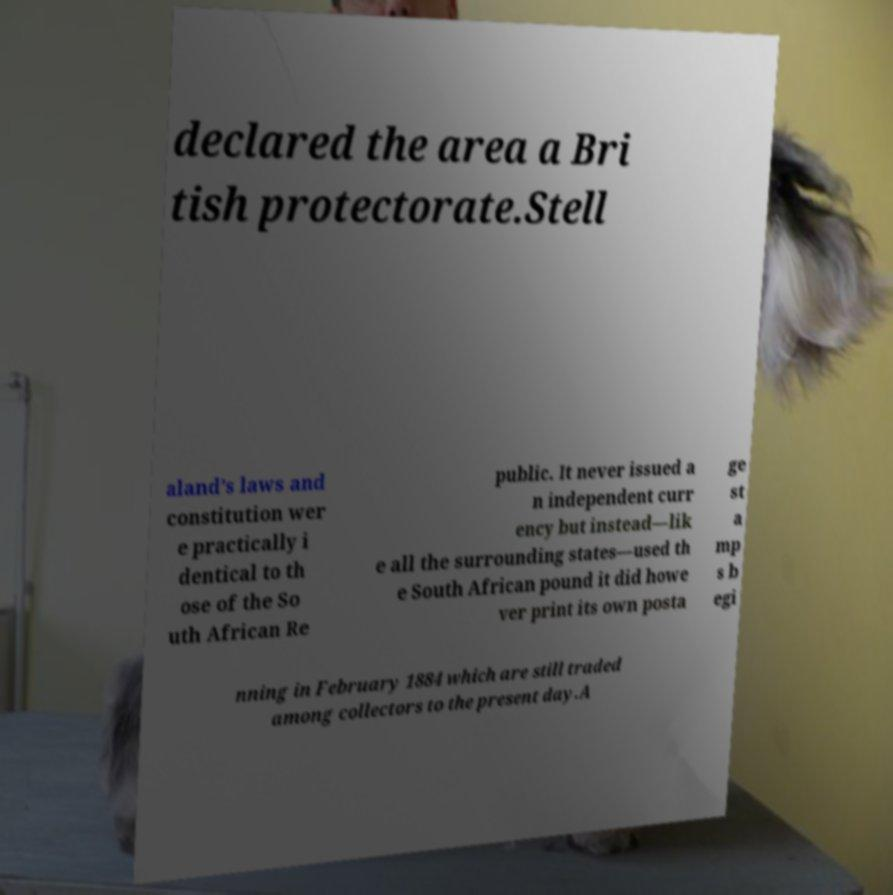I need the written content from this picture converted into text. Can you do that? declared the area a Bri tish protectorate.Stell aland’s laws and constitution wer e practically i dentical to th ose of the So uth African Re public. It never issued a n independent curr ency but instead—lik e all the surrounding states—used th e South African pound it did howe ver print its own posta ge st a mp s b egi nning in February 1884 which are still traded among collectors to the present day.A 